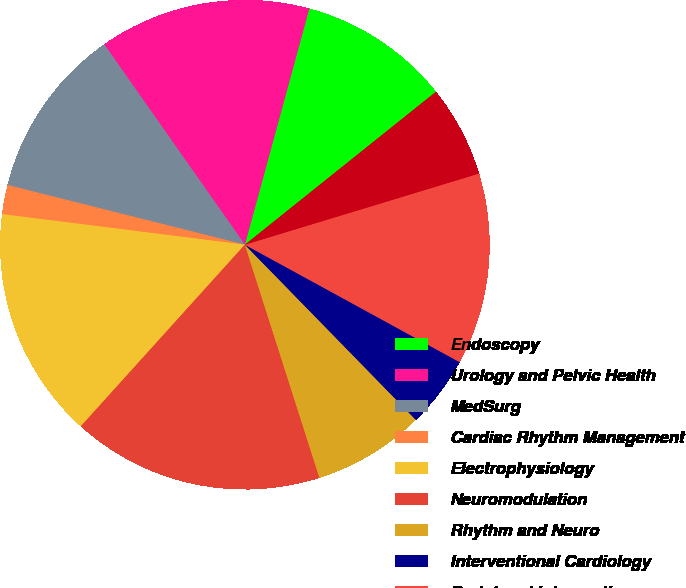Convert chart. <chart><loc_0><loc_0><loc_500><loc_500><pie_chart><fcel>Endoscopy<fcel>Urology and Pelvic Health<fcel>MedSurg<fcel>Cardiac Rhythm Management<fcel>Electrophysiology<fcel>Neuromodulation<fcel>Rhythm and Neuro<fcel>Interventional Cardiology<fcel>Peripheral Interventions<fcel>Cardiovascular<nl><fcel>10.02%<fcel>13.98%<fcel>11.34%<fcel>1.93%<fcel>15.3%<fcel>16.62%<fcel>7.38%<fcel>4.73%<fcel>12.66%<fcel>6.05%<nl></chart> 